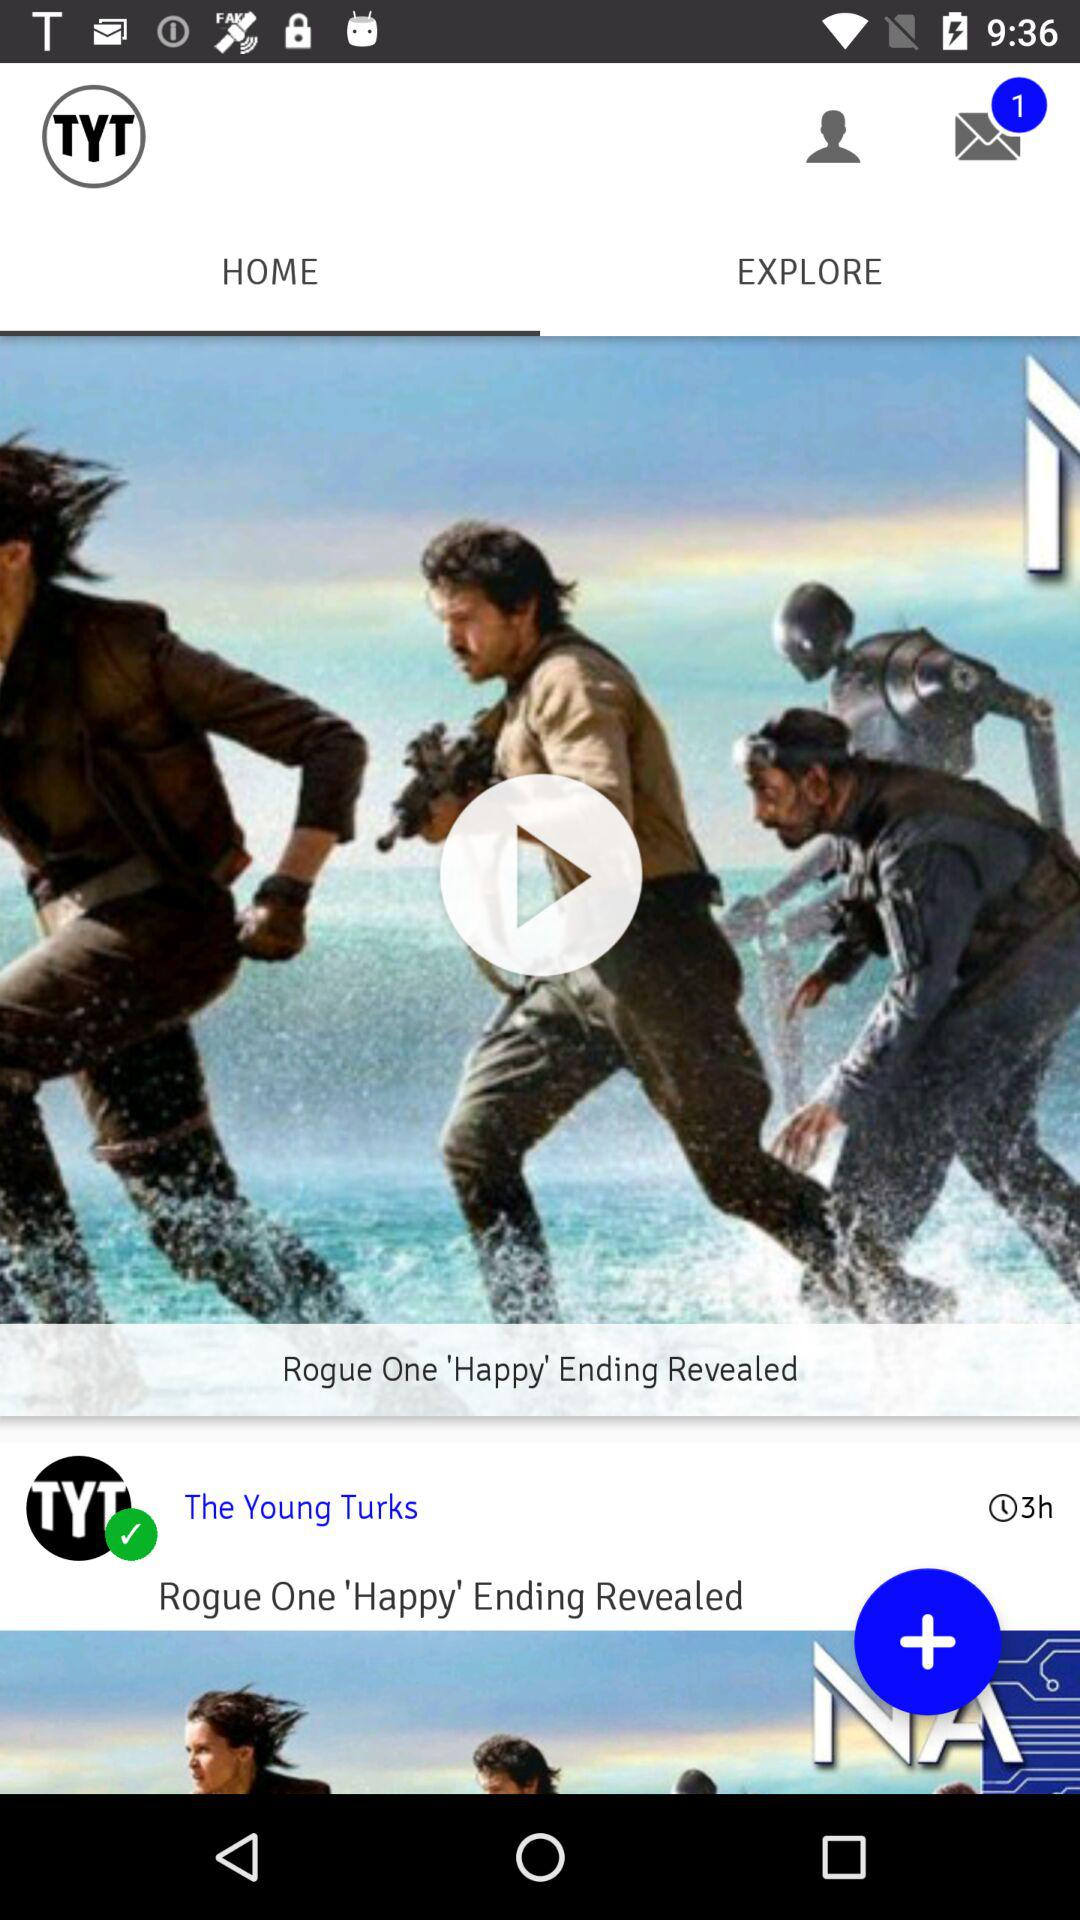Is there any unread message? There is 1 unread message. 